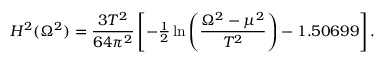Convert formula to latex. <formula><loc_0><loc_0><loc_500><loc_500>H ^ { 2 } ( \Omega ^ { 2 } ) = \frac { 3 T ^ { 2 } } { 6 4 \pi ^ { 2 } } \left [ - { \frac { 1 } { 2 } } \ln \left ( \frac { \Omega ^ { 2 } - \mu ^ { 2 } } { T ^ { 2 } } \right ) - 1 . 5 0 6 9 9 \right ] .</formula> 